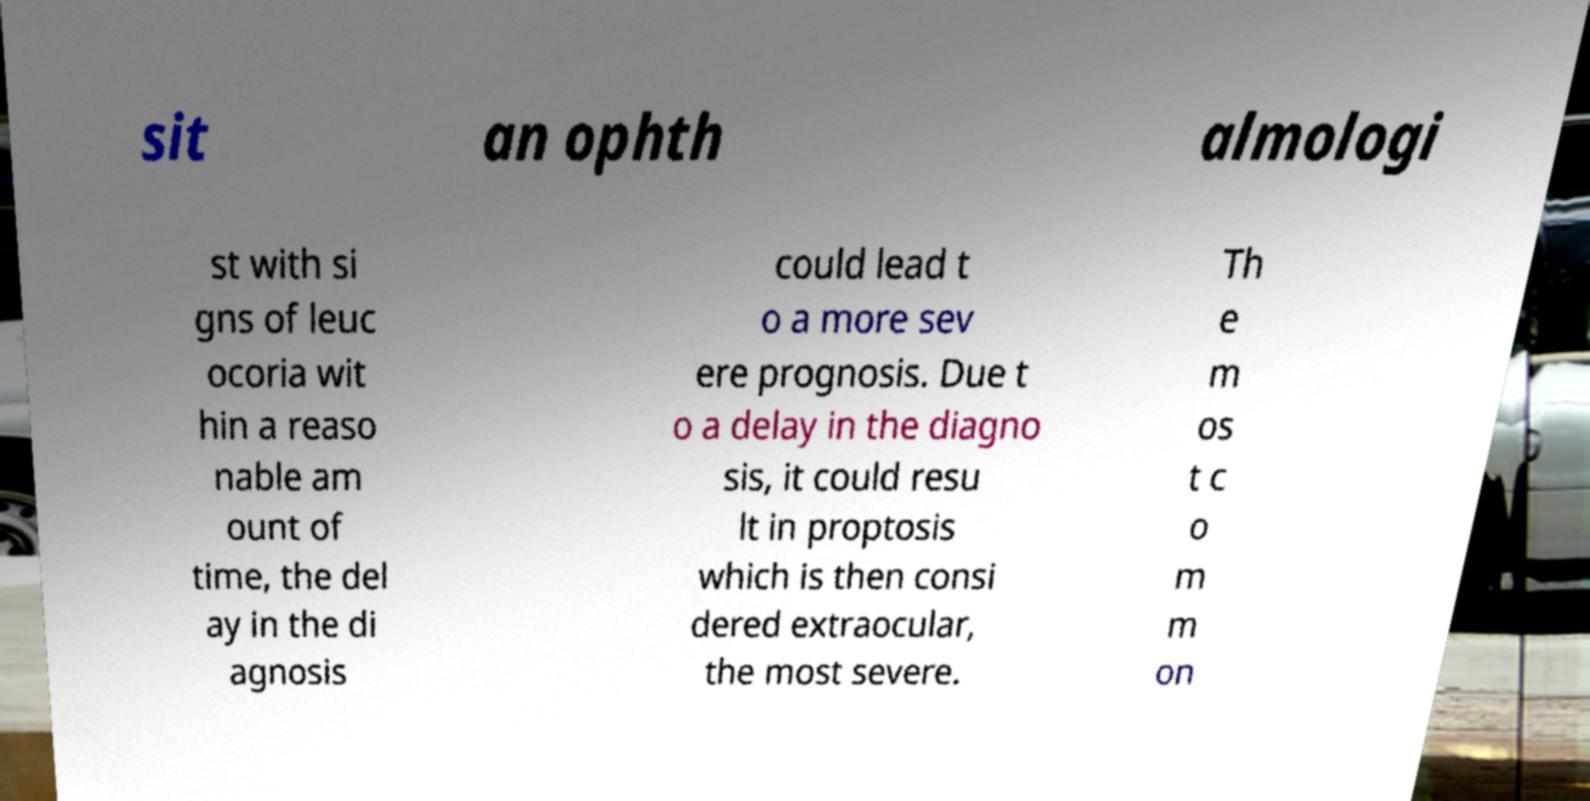Please read and relay the text visible in this image. What does it say? sit an ophth almologi st with si gns of leuc ocoria wit hin a reaso nable am ount of time, the del ay in the di agnosis could lead t o a more sev ere prognosis. Due t o a delay in the diagno sis, it could resu lt in proptosis which is then consi dered extraocular, the most severe. Th e m os t c o m m on 